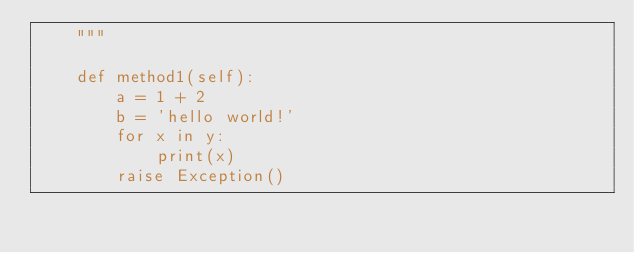Convert code to text. <code><loc_0><loc_0><loc_500><loc_500><_Python_>    """

    def method1(self):
        a = 1 + 2
        b = 'hello world!'
        for x in y:
            print(x)
        raise Exception()
</code> 